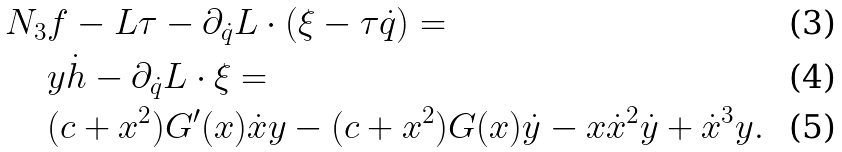<formula> <loc_0><loc_0><loc_500><loc_500>N _ { 3 } & f - L \tau - \partial _ { \dot { q } } L \cdot \left ( \xi - \tau \dot { q } \right ) = \\ & y \dot { h } - \partial _ { \dot { q } } L \cdot \xi = \\ & ( c + x ^ { 2 } ) G ^ { \prime } ( x ) \dot { x } y - ( c + x ^ { 2 } ) G ( x ) \dot { y } - x \dot { x } ^ { 2 } \dot { y } + \dot { x } ^ { 3 } y .</formula> 